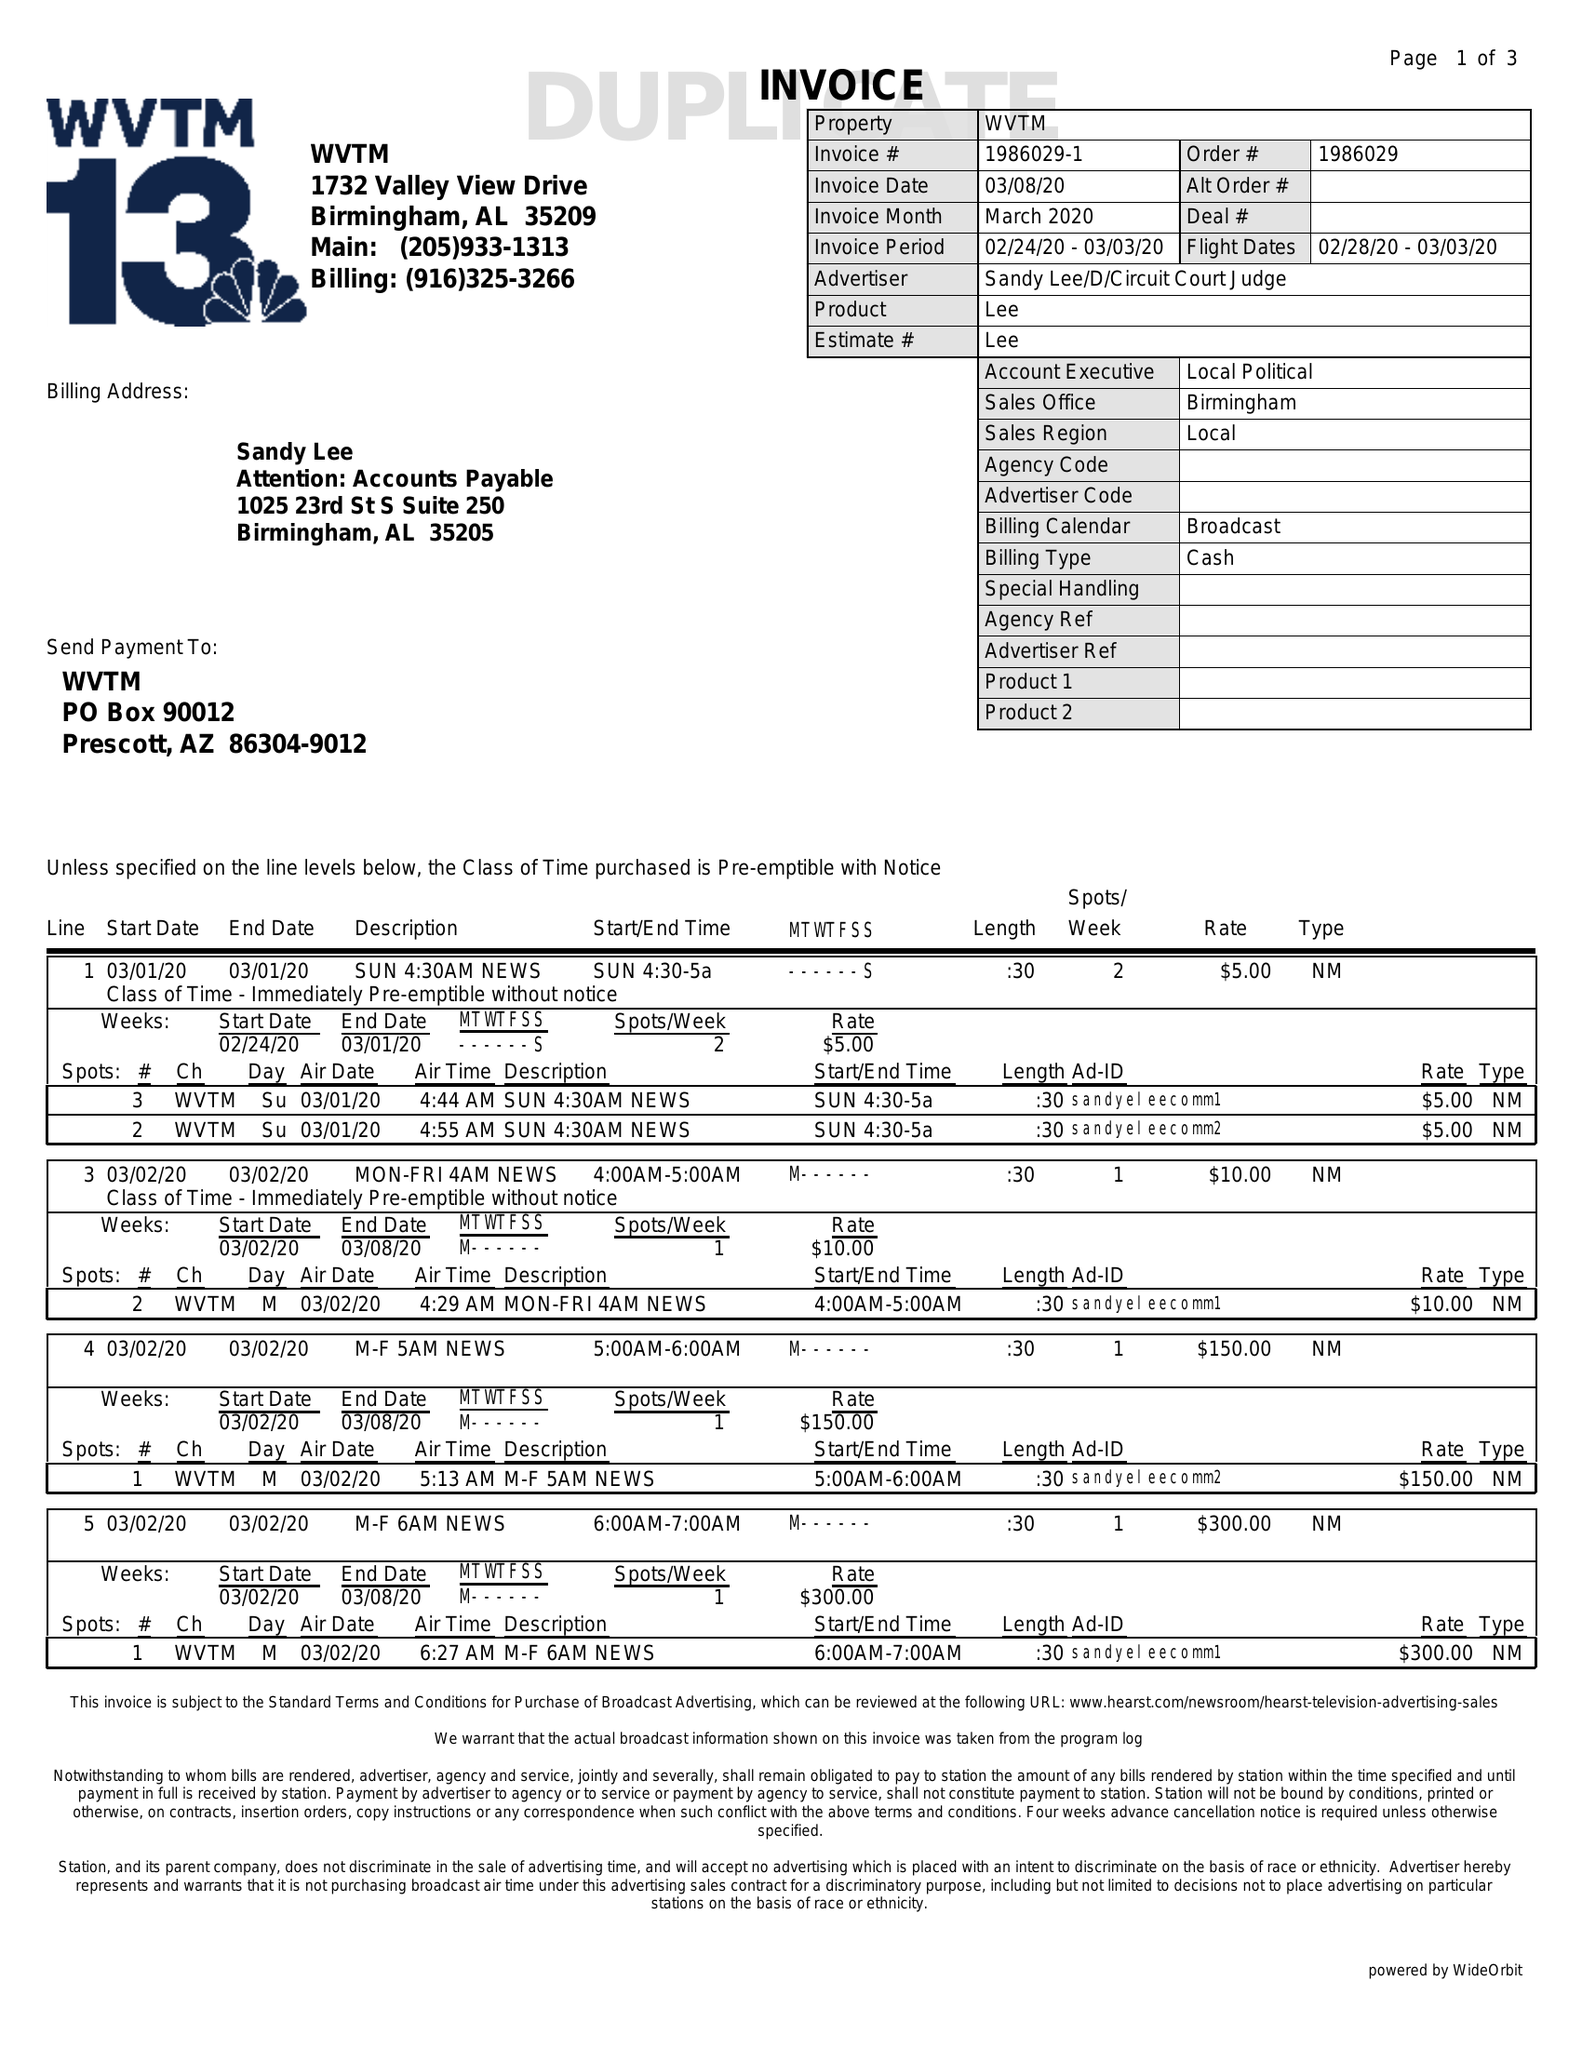What is the value for the advertiser?
Answer the question using a single word or phrase. SANDYLEE/D/CIRCUITCOURTJUDGE 